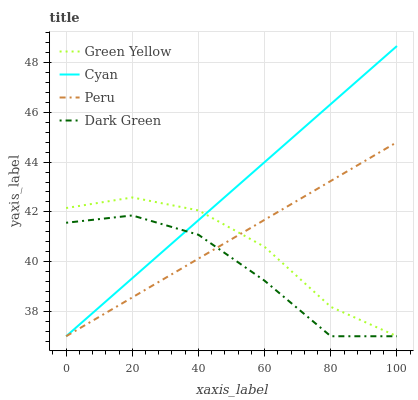Does Dark Green have the minimum area under the curve?
Answer yes or no. Yes. Does Cyan have the maximum area under the curve?
Answer yes or no. Yes. Does Green Yellow have the minimum area under the curve?
Answer yes or no. No. Does Green Yellow have the maximum area under the curve?
Answer yes or no. No. Is Peru the smoothest?
Answer yes or no. Yes. Is Dark Green the roughest?
Answer yes or no. Yes. Is Green Yellow the smoothest?
Answer yes or no. No. Is Green Yellow the roughest?
Answer yes or no. No. Does Cyan have the lowest value?
Answer yes or no. Yes. Does Cyan have the highest value?
Answer yes or no. Yes. Does Green Yellow have the highest value?
Answer yes or no. No. Does Cyan intersect Dark Green?
Answer yes or no. Yes. Is Cyan less than Dark Green?
Answer yes or no. No. Is Cyan greater than Dark Green?
Answer yes or no. No. 